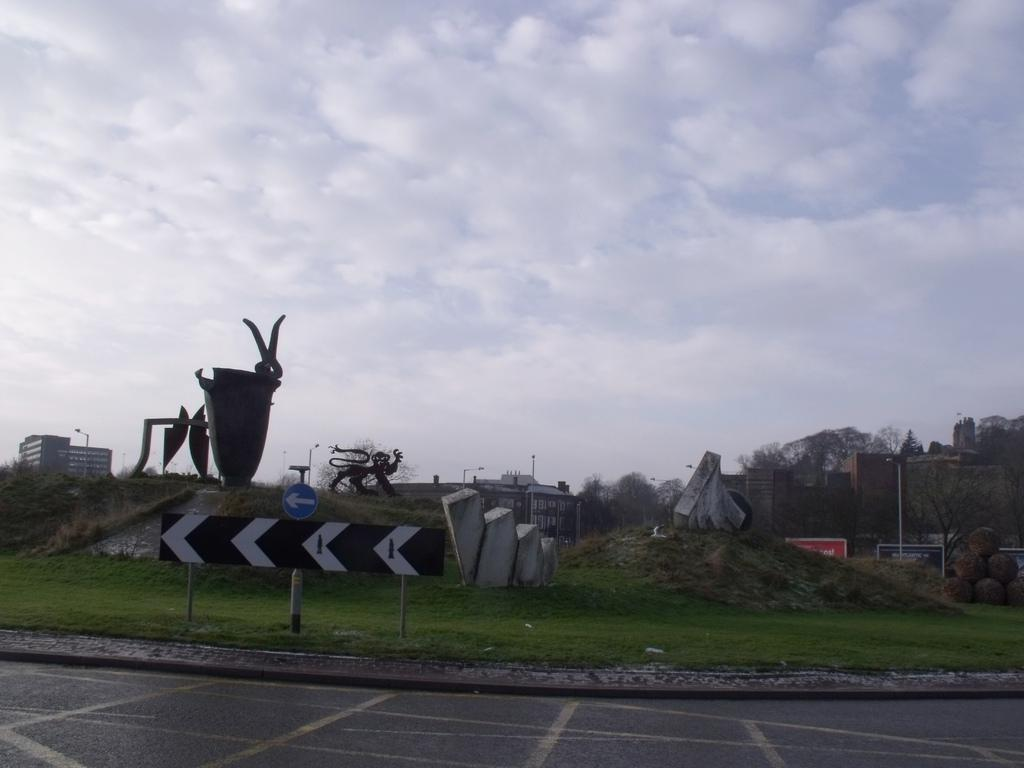What is located at the bottom of the image? There is a road at the bottom of the image. What can be seen in the center of the image? There are statues, rock structures, grass, trees, and buildings in the center of the image. What is visible in the background of the image? The sky is visible in the background of the image. How many roses are present in the image? There are no roses visible in the image. Can you tell me where the boat is located in the image? There is no boat present in the image. 